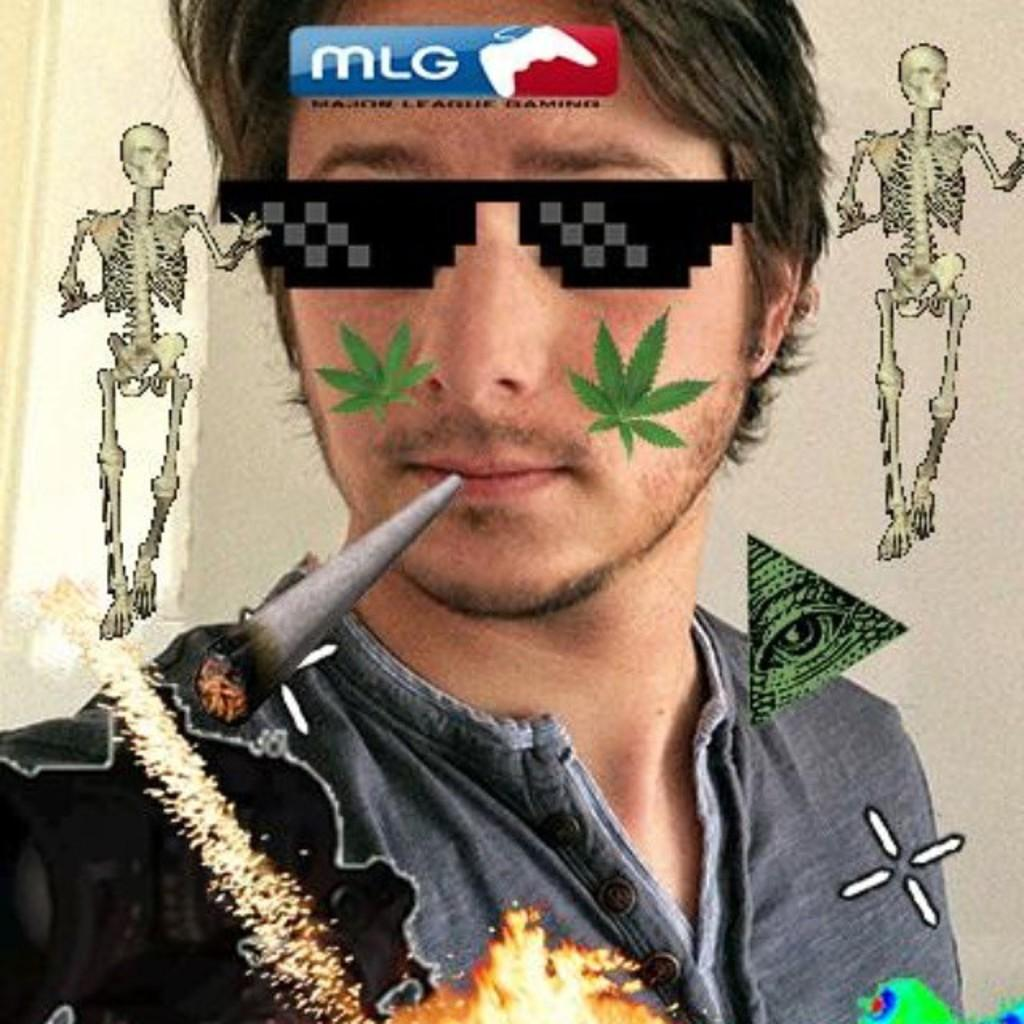What is the main subject of the image? The main subject of the image is a person's face. How has the person's face been edited in the image? The face has been edited with a cigarette, goggles, skeletons, and leaves. Can you describe the specific edits made to the face? The face has been edited with a cigarette, goggles, skeletons, and leaves. What type of skin condition can be seen on the person's face in the image? There is no mention of a skin condition in the image; the face has been edited with a cigarette, goggles, skeletons, and leaves. How does the wind affect the person's face in the image? There is no mention of wind in the image; the focus is on the edited elements of the face. 